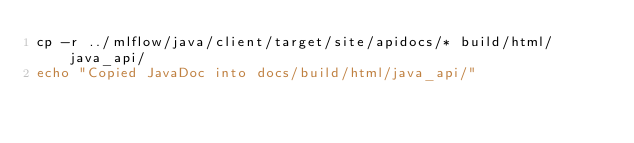Convert code to text. <code><loc_0><loc_0><loc_500><loc_500><_Bash_>cp -r ../mlflow/java/client/target/site/apidocs/* build/html/java_api/
echo "Copied JavaDoc into docs/build/html/java_api/"
</code> 